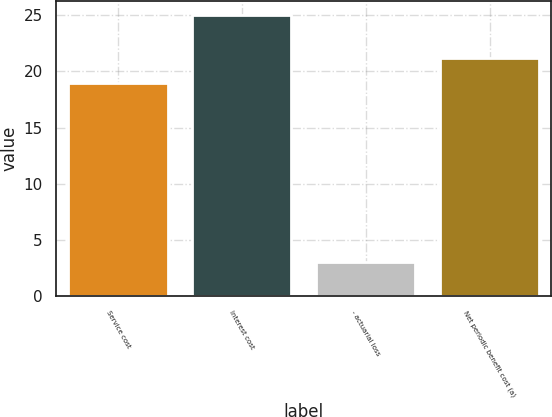<chart> <loc_0><loc_0><loc_500><loc_500><bar_chart><fcel>Service cost<fcel>Interest cost<fcel>- actuarial loss<fcel>Net periodic benefit cost (a)<nl><fcel>19<fcel>25<fcel>3<fcel>21.2<nl></chart> 